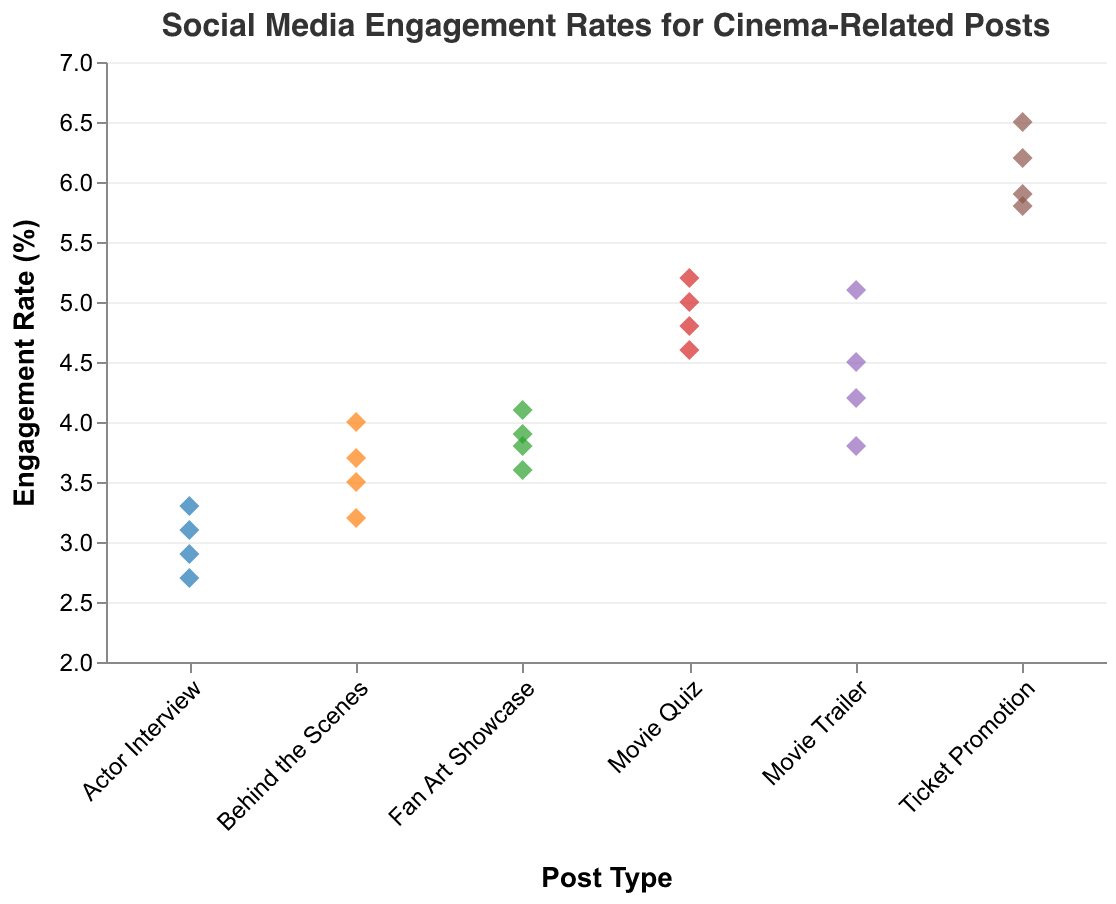What post type has the highest engagement rate? Based on the plot, the highest engagement rate is represented by the highest point on the y-axis. The highest engagement rate is indicated by a "Ticket Promotion" post type at 6.5%.
Answer: Ticket Promotion What is the range of engagement rates for "Movie Trailers"? The engagement rates for "Movie Trailer" posts are between 3.8% and 5.1% as the lowest and highest points on the y-axis for this post type.
Answer: 1.3% Which post type has the most dispersed engagement rates? By observing the vertical spread of points for each post type, "Ticket Promotion" has the most dispersed engagement rates, ranging from 5.8% to 6.5%.
Answer: Ticket Promotion How many "Actor Interview" posts have an engagement rate below 3%? There are two "Actor Interview" points plotted below 3% on the y-axis.
Answer: 2 What is the average engagement rate for "Behind the Scenes" posts? The engagement rates for "Behind the Scenes" posts are 3.7%, 3.2%, 4.0%, and 3.5%. Summing these gives 14.4%. Dividing by 4 (the number of posts) gives an average of 3.6%.
Answer: 3.6% Compare the median engagement rates of "Fan Art Showcase" and "Movie Quiz". Which is higher? The engagement rates for "Fan Art Showcase" are 3.6%, 3.8%, 3.9%, and 4.1%. The median is the average of the middle two numbers, (3.8+3.9)/2 = 3.85%. For "Movie Quiz," the rates are 4.6%, 4.8%, 5.0%, and 5.2%, with a median of (4.8+5.0)/2 = 4.9%. The median for "Movie Quiz" is higher.
Answer: Movie Quiz What post type has the lowest engagement rate? The lowest engagement rate on the y-axis is associated with "Actor Interview" at 2.7%.
Answer: Actor Interview What is the total number of posts analyzed in the plot? The plot shows 24 points, each representing one post type with its engagement rate.
Answer: 24 Which post type has more posts with an engagement rate above 5%? "Movie Trailer" or "Movie Quiz"? "Movie Trailers" have one post above 5%, while "Movie Quiz" has three. Hence, "Movie Quiz" has more posts with an engagement rate above 5%.
Answer: Movie Quiz 